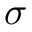<formula> <loc_0><loc_0><loc_500><loc_500>\sigma</formula> 